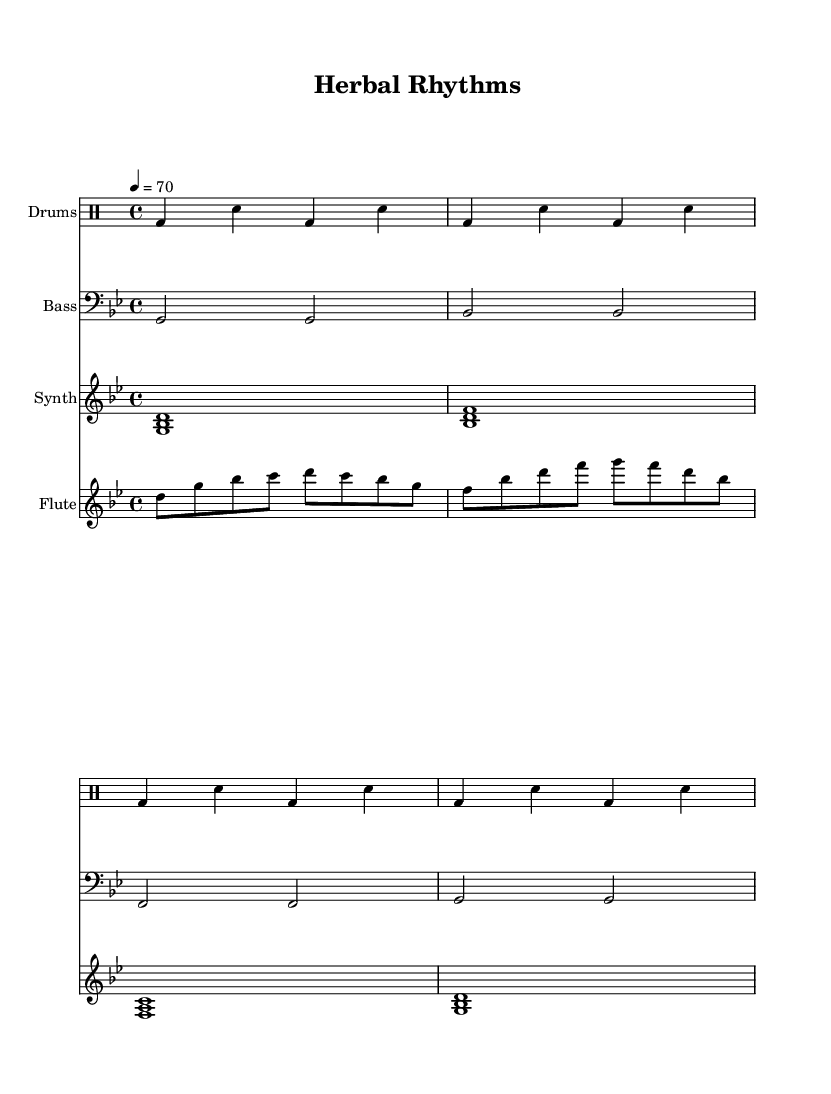What is the key signature of this music? The key signature is G minor, which has two flats (B flat and E flat) indicated at the beginning of the staff.
Answer: G minor What is the time signature of this music? The time signature is marked as 4/4, meaning there are four beats in each measure and the quarter note gets one beat.
Answer: 4/4 What is the tempo of this piece? The tempo is indicated by the marking "4 = 70", which denotes that each quarter note should be played at a speed of 70 beats per minute.
Answer: 70 How many measures are in the drum part? By counting the individual measures notated in the drum part, we see there are four repetitions of the same pattern, giving us a total of four measures.
Answer: 4 Which instrument plays the highest pitch? Looking at the relative pitch of the parts, the flute section is the one that reaches the highest notes, especially with notes like C and D that are higher than the other instruments.
Answer: Flute What type of musical scales are used in the synth part? The synth part primarily uses triads based on the G minor scale (G, B flat, and D), indicating the use of minor chords typically associated with hip-hop music.
Answer: Minor chords How does the combination of nature sounds and hip-hop beats contribute to the ambiance? The mixing of relaxed natural sounds, like flute melodies, with consistent hip-hop beats creates a calming environment perfect for gardening or relaxation, highlighting the genre's versatility.
Answer: Calming ambiance 